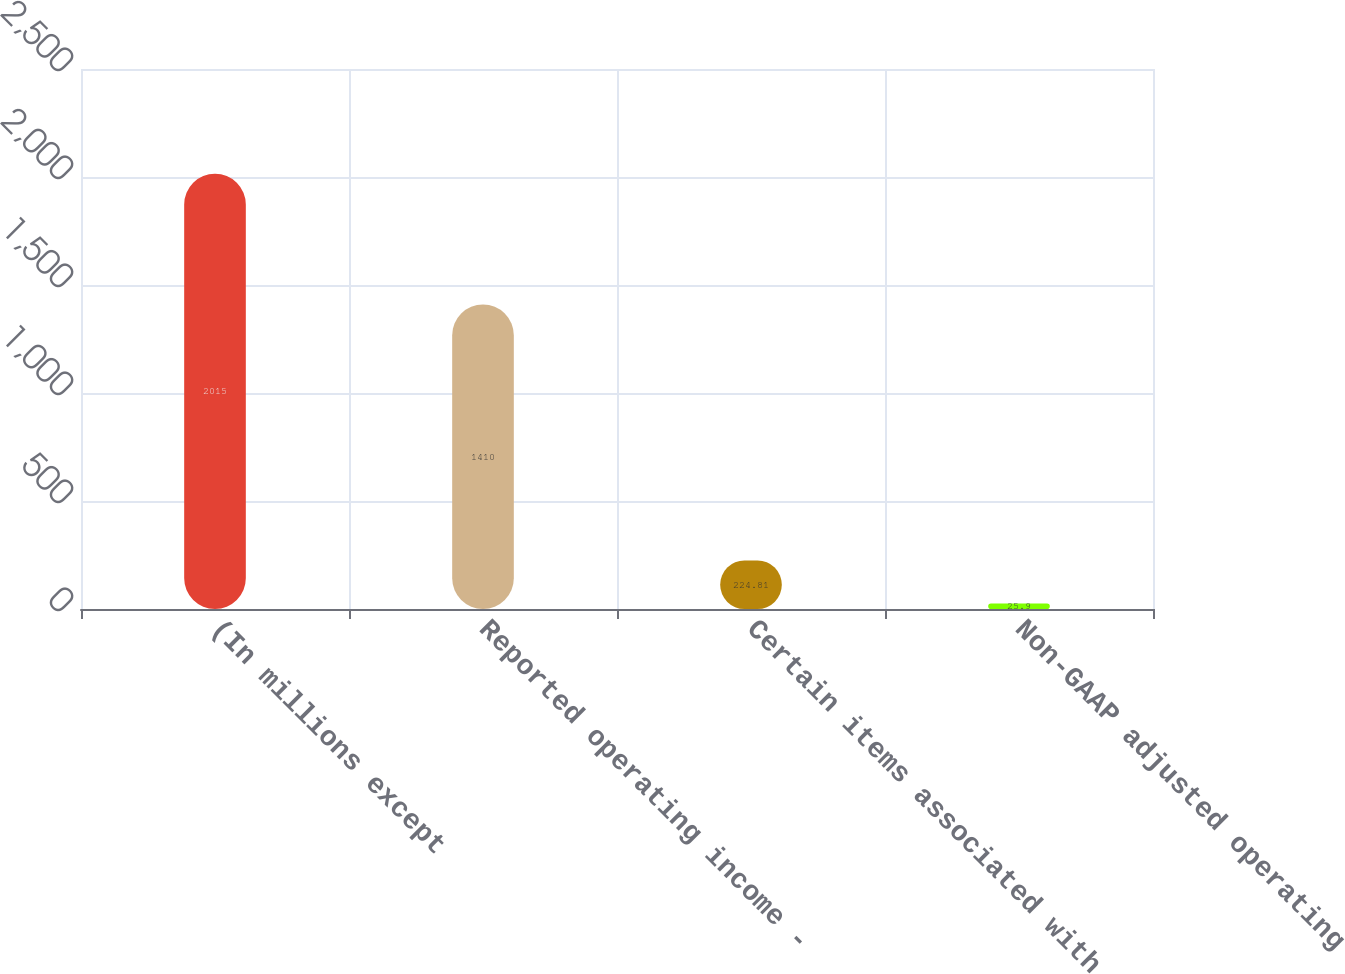<chart> <loc_0><loc_0><loc_500><loc_500><bar_chart><fcel>(In millions except<fcel>Reported operating income -<fcel>Certain items associated with<fcel>Non-GAAP adjusted operating<nl><fcel>2015<fcel>1410<fcel>224.81<fcel>25.9<nl></chart> 